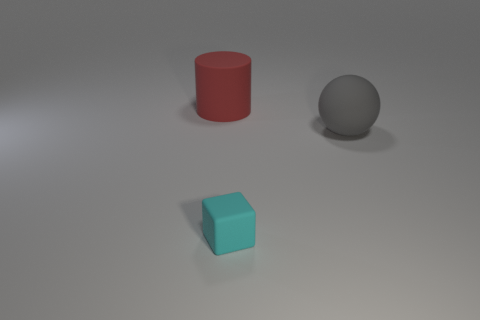How many matte objects are there?
Offer a very short reply. 3. Is the large thing that is on the left side of the sphere made of the same material as the small cyan object?
Keep it short and to the point. Yes. What is the material of the thing that is to the left of the gray rubber thing and behind the small object?
Offer a terse response. Rubber. There is a large object in front of the big thing to the left of the large gray object; what is its material?
Give a very brief answer. Rubber. What is the size of the thing that is in front of the big thing in front of the big object that is behind the gray rubber ball?
Make the answer very short. Small. What number of big blue cylinders are made of the same material as the big gray ball?
Your response must be concise. 0. What color is the big rubber object right of the big object that is behind the gray thing?
Your answer should be compact. Gray. What number of objects are tiny brown metallic cylinders or big gray matte spheres that are on the right side of the large cylinder?
Make the answer very short. 1. Are there any small cubes of the same color as the big ball?
Provide a short and direct response. No. What number of gray things are large balls or big objects?
Offer a very short reply. 1. 